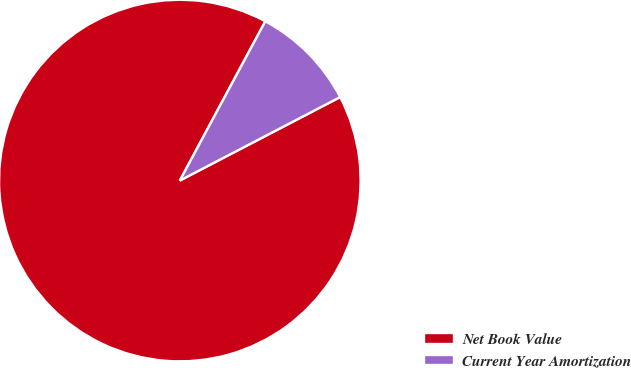Convert chart to OTSL. <chart><loc_0><loc_0><loc_500><loc_500><pie_chart><fcel>Net Book Value<fcel>Current Year Amortization<nl><fcel>90.48%<fcel>9.52%<nl></chart> 